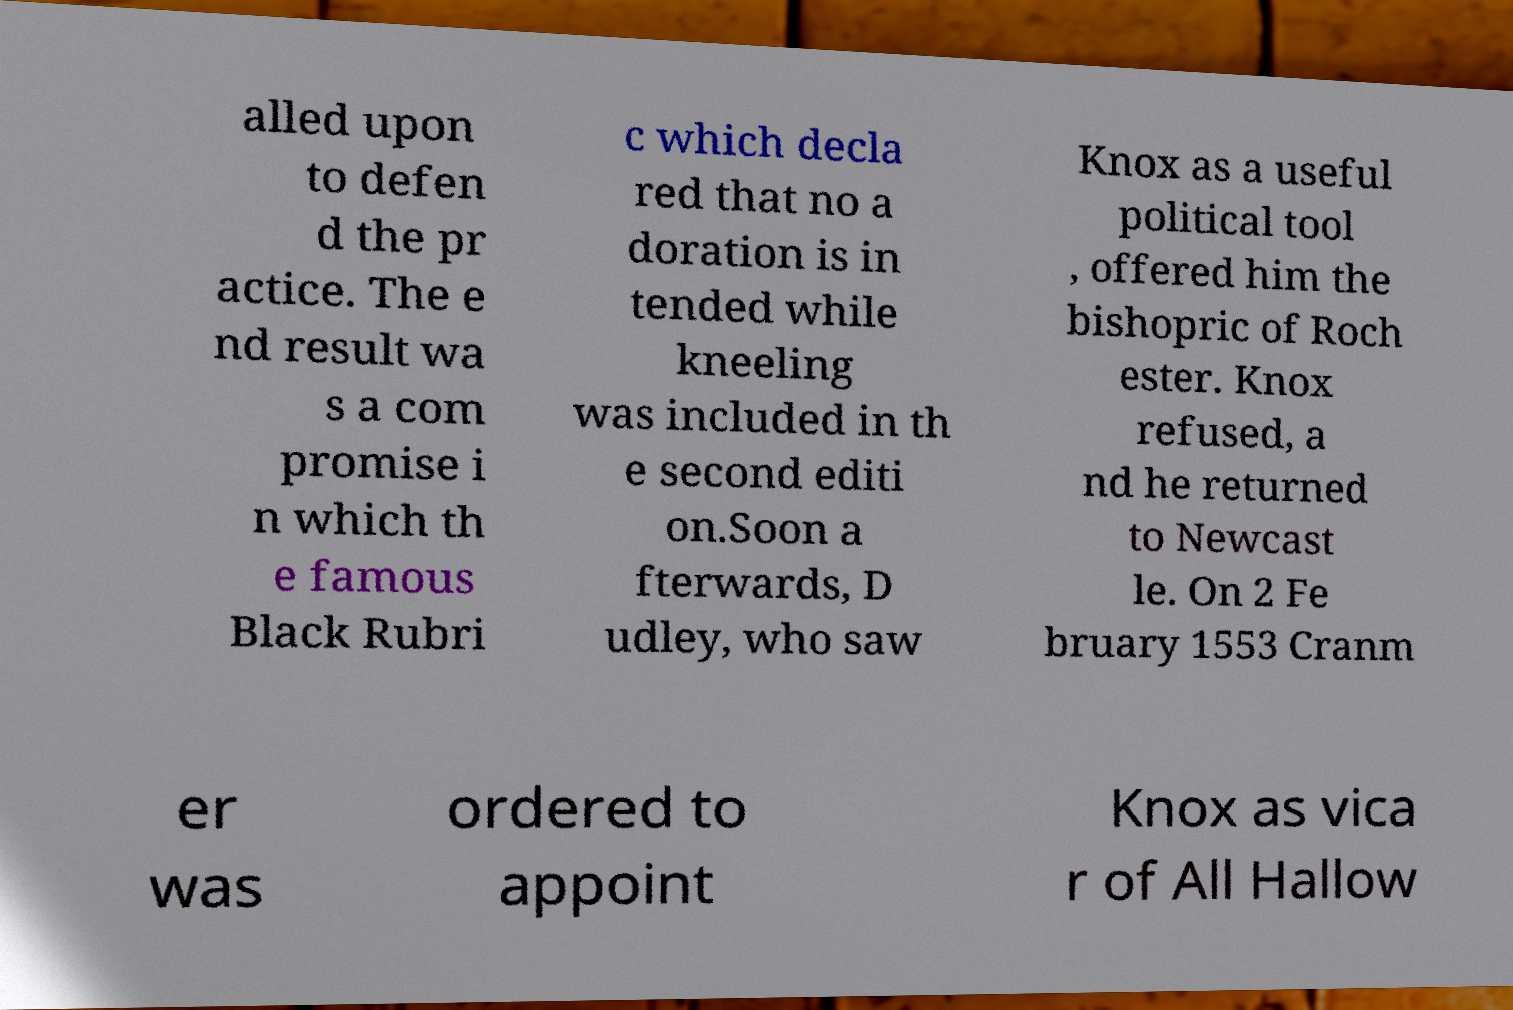I need the written content from this picture converted into text. Can you do that? alled upon to defen d the pr actice. The e nd result wa s a com promise i n which th e famous Black Rubri c which decla red that no a doration is in tended while kneeling was included in th e second editi on.Soon a fterwards, D udley, who saw Knox as a useful political tool , offered him the bishopric of Roch ester. Knox refused, a nd he returned to Newcast le. On 2 Fe bruary 1553 Cranm er was ordered to appoint Knox as vica r of All Hallow 